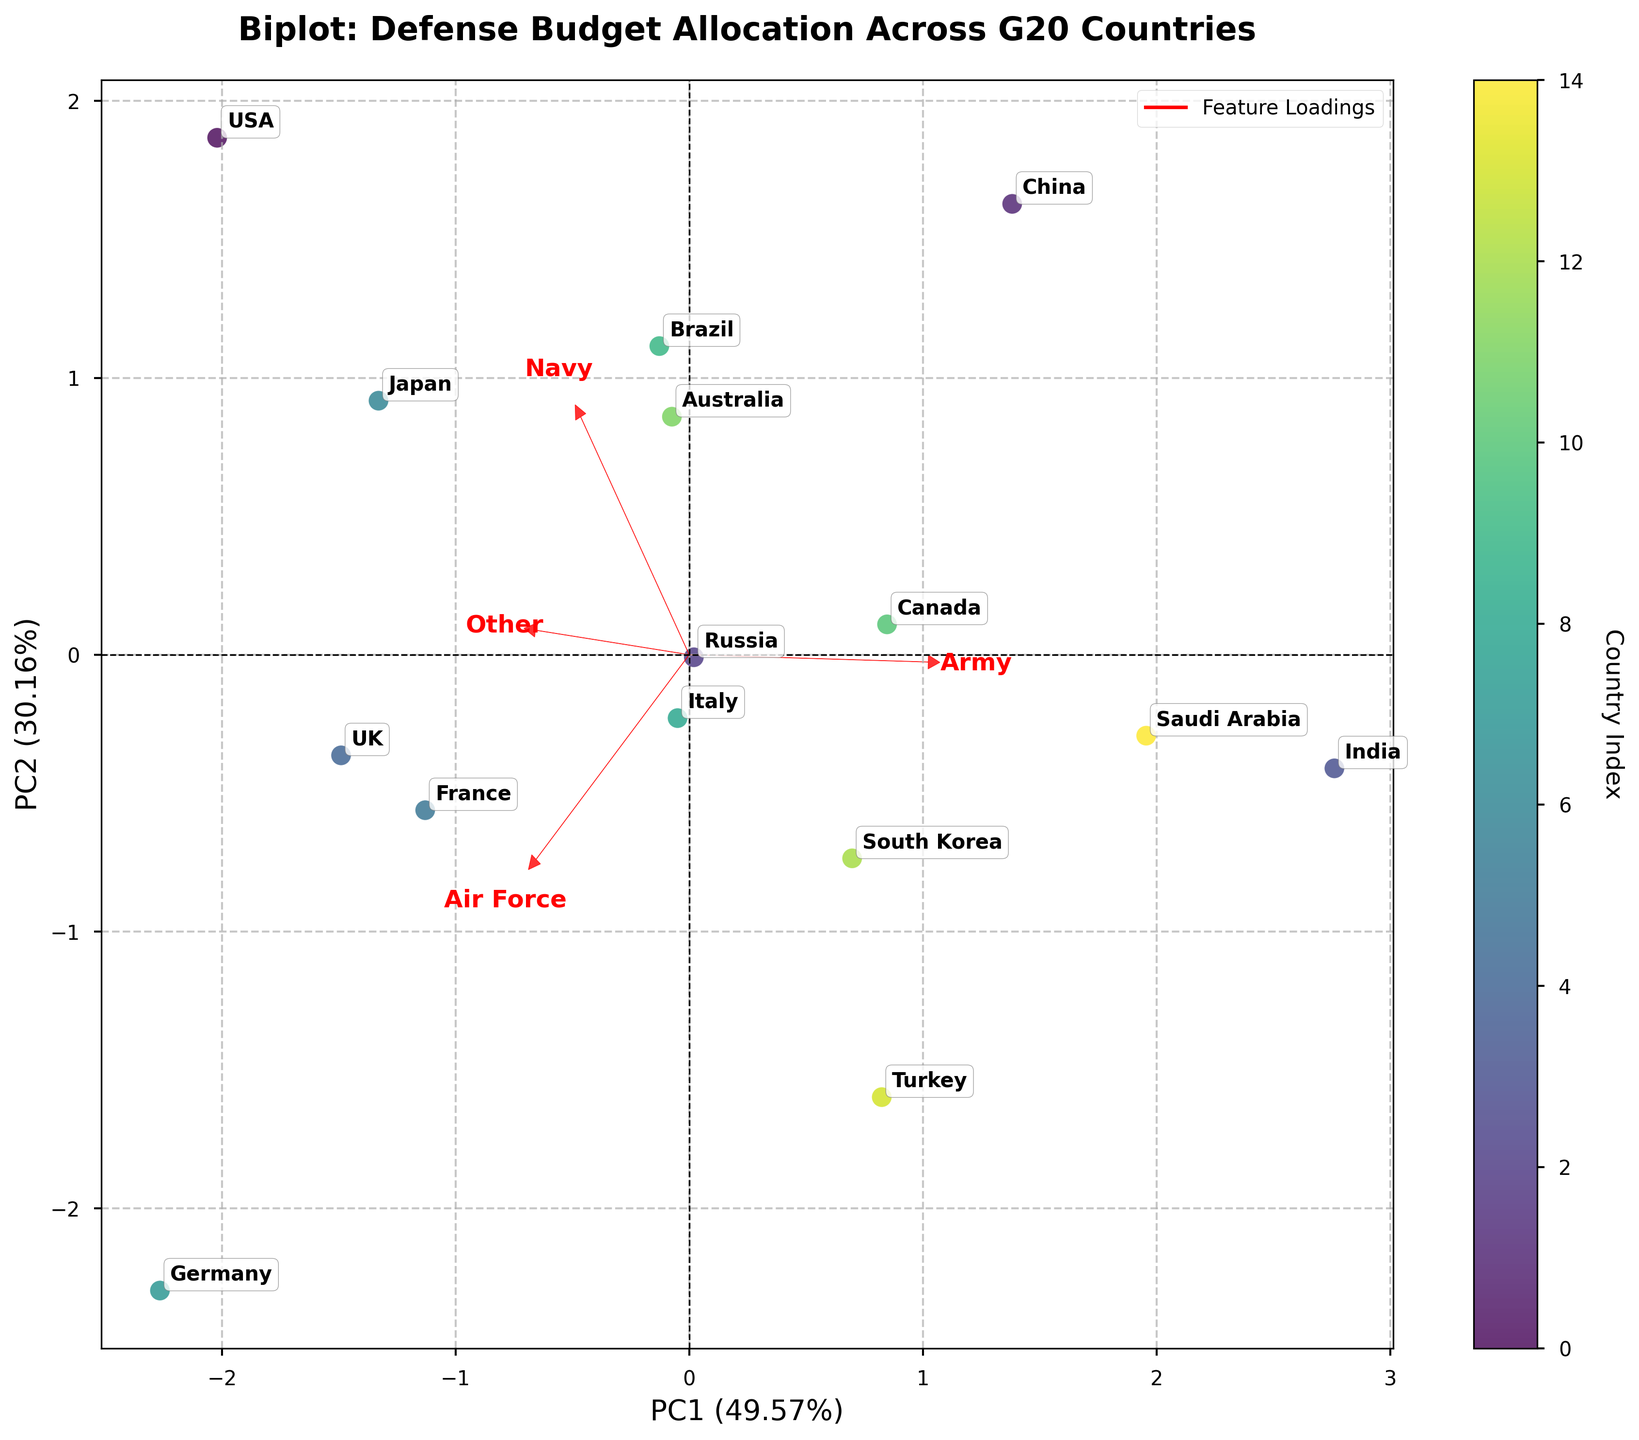Which country has the highest allocation in the Army? By checking the country's Army percentage on the arrows pointing out from the origin and comparing them, India has the highest allocation at 56.3%.
Answer: India Which two countries are closest to each other in the biplot? By observing the scatter plot and identifying countries positioned close to each other, Russia and Brazil appear to be nearest.
Answer: Russia and Brazil How much variance do the first and second principal components explain together? The explained variance percentages for PC1 and PC2 are displayed on the axes; summing them up gives PC1 (x%) and PC2 (y%), which together explain around (x+y)% variance.
Answer: Approximately 85% Which feature is most strongly associated with PC1? The length and angle of the arrows represent the loadings, and the feature with the longest arrow parallel to PC1 is the most associated. The Army's arrow is closest to the direction of PC1.
Answer: Army Which country has the lowest allocation in the 'Other' category? By examining the arrows representing each feature and comparing the 'Other' percentages, South Korea has the lowest allocation at 3.3%.
Answer: South Korea What is the PC1 coordinate for the United States? Locate the point labeled "USA" and check its horizontal coordinate to identify its PC1 value.
Answer: Approximately -1.5 Which countries have higher allocations in the Navy compared to Turkey? Identify the countries on the scatter plot and check their Navy percentages; the countries with higher Navy allocations than Turkey (14.2%) are plotted ahead. For example, USA, Brazil, and Australia have higher allocations.
Answer: USA, Brazil, Australia Between Germany and Japan, which has a higher allocation in the Air Force? Compare the positioning and the direction of the Air Force arrow; Germany's arrow is longer in this direction, indicating that Germany has a higher Air Force allocation.
Answer: Germany What does an arrow's length represent in the biplot? Arrows represent feature loadings, and their length correlates with the strength of the feature's contribution to the respective principal component.
Answer: Feature strength How can you interpret the opposing direction of the Army and Air Force arrows? The directions suggest that countries with high Army allocations tend to have low Air Force allocations and vice versa, as indicated by the arrows pointing in almost opposite directions.
Answer: Opposite allocation trends 